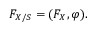<formula> <loc_0><loc_0><loc_500><loc_500>F _ { X / S } = ( F _ { X } , \varphi ) .</formula> 